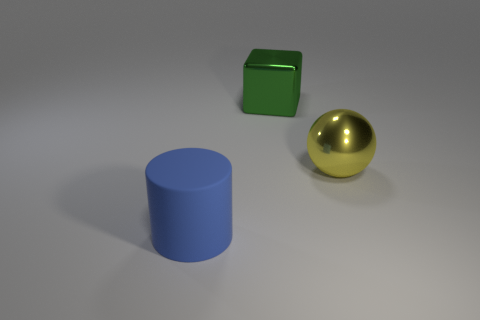Do the big yellow sphere and the big thing that is left of the big metallic cube have the same material?
Your answer should be compact. No. Are there more large objects that are on the right side of the large cylinder than big green metallic objects?
Provide a short and direct response. Yes. Is the number of large blue rubber cylinders that are in front of the large green metal block the same as the number of shiny blocks that are in front of the blue matte thing?
Your answer should be very brief. No. What is the thing that is behind the yellow shiny ball made of?
Your response must be concise. Metal. What number of things are things behind the blue cylinder or small green metal balls?
Give a very brief answer. 2. How many other objects are there of the same shape as the large blue object?
Give a very brief answer. 0. Are there any blue matte cylinders in front of the big yellow object?
Provide a short and direct response. Yes. What number of large objects are either green matte cubes or green shiny things?
Provide a short and direct response. 1. Is the yellow object made of the same material as the large cylinder?
Your answer should be very brief. No. What is the shape of the metallic object to the left of the big metallic thing that is in front of the large object that is behind the big yellow sphere?
Your answer should be very brief. Cube. 